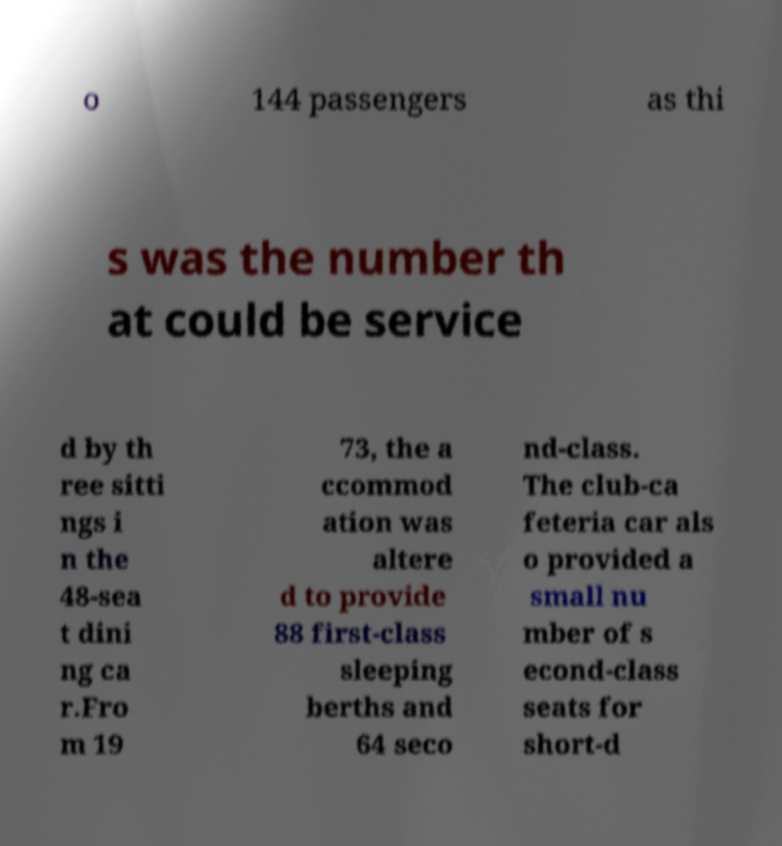Can you read and provide the text displayed in the image?This photo seems to have some interesting text. Can you extract and type it out for me? o 144 passengers as thi s was the number th at could be service d by th ree sitti ngs i n the 48-sea t dini ng ca r.Fro m 19 73, the a ccommod ation was altere d to provide 88 first-class sleeping berths and 64 seco nd-class. The club-ca feteria car als o provided a small nu mber of s econd-class seats for short-d 